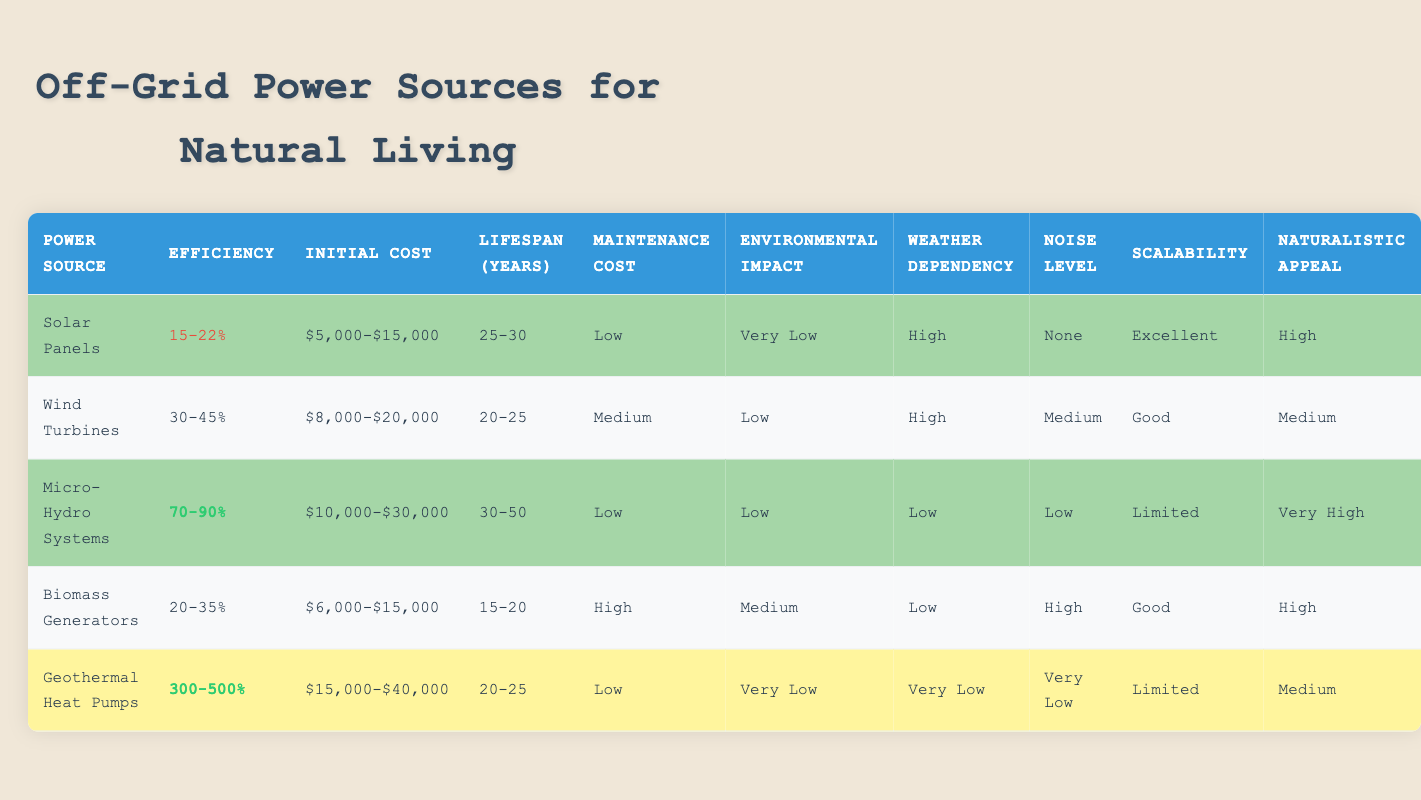What is the efficiency range of Micro-Hydro Systems? According to the table, the efficiency range of Micro-Hydro Systems is 70-90%.
Answer: 70-90% Which power source has the lowest maintenance cost? The table lists both Solar Panels and Micro-Hydro Systems as having a low maintenance cost. However, including the context of this question, Solar Panels is the first listed as having low maintenance.
Answer: Solar Panels How many years can Wind Turbines last at most? The table indicates that Wind Turbines have a lifespan of 20-25 years, where 25 is the maximum.
Answer: 25 What is the combined efficiency of Solar Panels and Biomass Generators? The efficiency of Solar Panels is 15-22% and for Biomass Generators is 20-35%. When combining the lower ends: 15% + 20% = 35%, and the upper ends: 22% + 35% = 57%, so the combined efficiency ranges from 35% to 57%.
Answer: 35-57% Is the noise level of Geothermal Heat Pumps very low? Yes, the table states that Geothermal Heat Pumps have a noise level of very low.
Answer: Yes Which power source has the highest naturalistic appeal? Looking at the table, Micro-Hydro Systems have the highest naturalistic appeal rating listing as very high compared to other sources.
Answer: Micro-Hydro Systems What is the average initial cost of all listed power sources? The initial costs are as follows: Solar Panels $10,000, Wind Turbines $14,000, Micro-Hydro Systems $20,000, Biomass Generators $10,500, and Geothermal Heat Pumps $27,500. Summing these gives: $10,000 + $14,000 + $20,000 + $10,500 + $27,500 = $82,000; now divide that by 5 gives an average initial cost of $16,400.
Answer: $16,400 Does Biomass Generators have an environmental impact rated as low? No, the table indicates that Biomass Generators have a medium environmental impact.
Answer: No Which power source is the most scalable? According to the table, Solar Panels have been classified with excellent scalability, more than others.
Answer: Solar Panels 